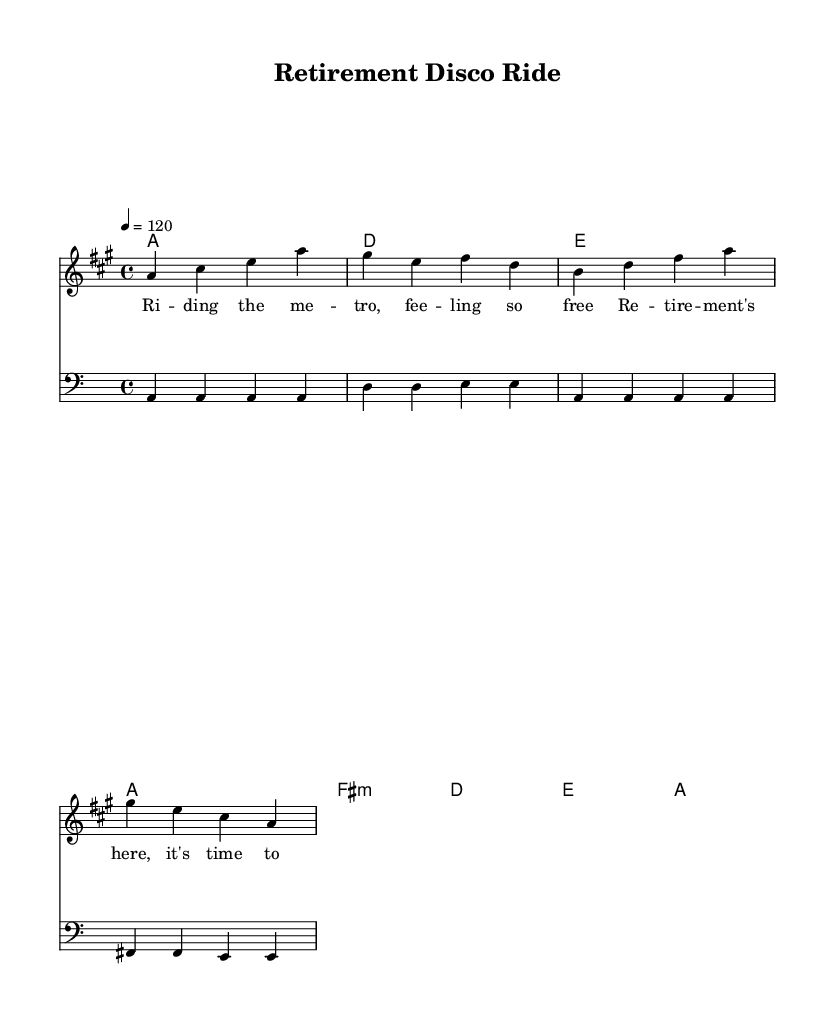What is the key signature of this music? The key signature indicated at the beginning of the sheet music shows that there are three sharps. This corresponds to A major, where the sharps are F#, C#, and G#.
Answer: A major What is the time signature of this music? The time signature is displayed at the beginning of the music sheet as 4/4. This means there are four beats in each measure and a quarter note receives one beat.
Answer: 4/4 What is the tempo marking for this piece? The tempo marking at the beginning indicates "4 = 120", meaning the tempo is set at 120 beats per minute, which is a common tempo for dance music, including disco.
Answer: 120 How many measures are there in the harmony section? The harmony section consists of four distinct measures, which can be counted from the chord symbols indicating each measure. Each chord symbol represents one measure.
Answer: 4 What is the role of the bass line in this piece? The bass line provides rhythmic and harmonic foundation, typically following the chord progression set in harmony, complementary to the melody. In disco music, the bass line often emphasizes the groove.
Answer: Foundation What is the lyrical theme of this music? The lyrics convey feelings of freedom and enjoyment associated with retirement, emphasizing the enjoyment of leisure time. Phrases like "feeling so free" and "it's time to be me" reflect a celebratory attitude towards retirement.
Answer: Freedom How does the melody relate to disco music characteristics? Disco melodies often feature catchy, repetitive phrases that encourage dancing. In this piece, the melody follows a simple, memorable pattern that captures the spirit of disco, designed to be enjoyable and engaging.
Answer: Catchy 